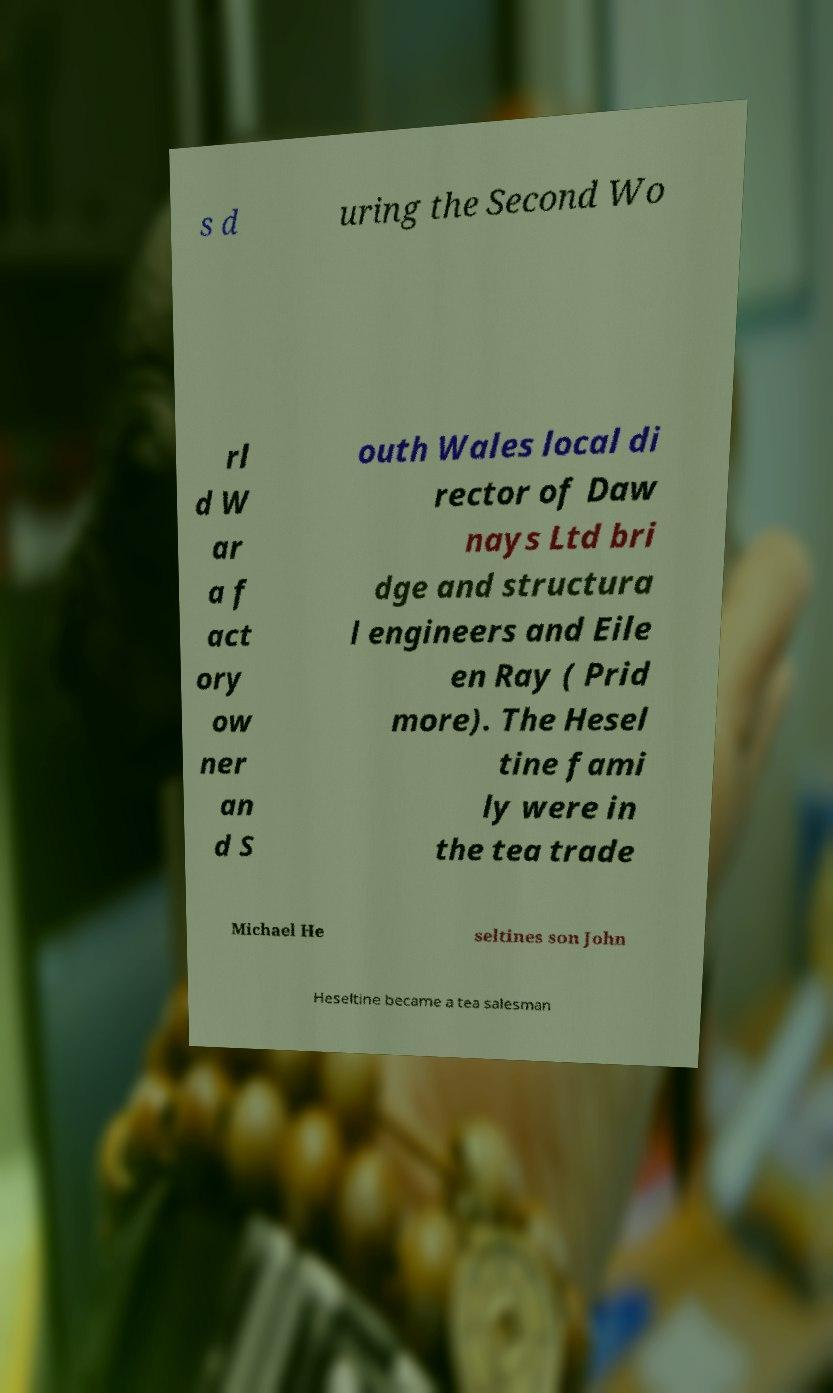I need the written content from this picture converted into text. Can you do that? s d uring the Second Wo rl d W ar a f act ory ow ner an d S outh Wales local di rector of Daw nays Ltd bri dge and structura l engineers and Eile en Ray ( Prid more). The Hesel tine fami ly were in the tea trade Michael He seltines son John Heseltine became a tea salesman 